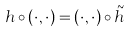<formula> <loc_0><loc_0><loc_500><loc_500>h \circ ( \cdot , \cdot ) = ( \cdot , \cdot ) \circ { \tilde { h } }</formula> 